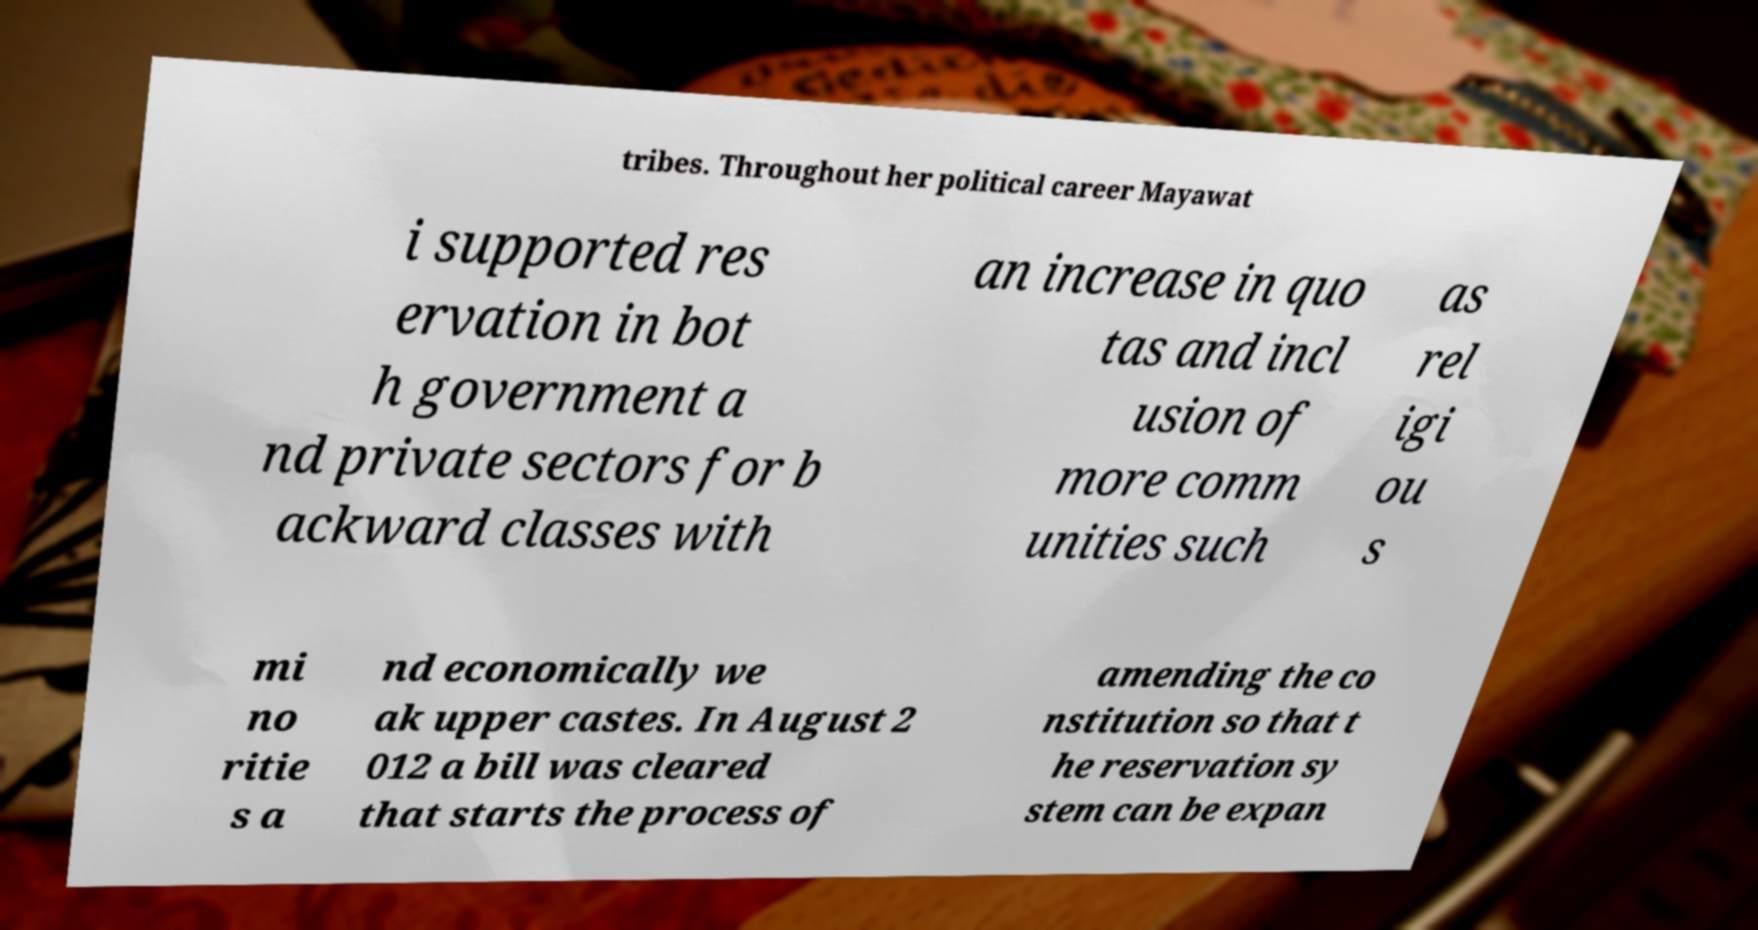I need the written content from this picture converted into text. Can you do that? tribes. Throughout her political career Mayawat i supported res ervation in bot h government a nd private sectors for b ackward classes with an increase in quo tas and incl usion of more comm unities such as rel igi ou s mi no ritie s a nd economically we ak upper castes. In August 2 012 a bill was cleared that starts the process of amending the co nstitution so that t he reservation sy stem can be expan 